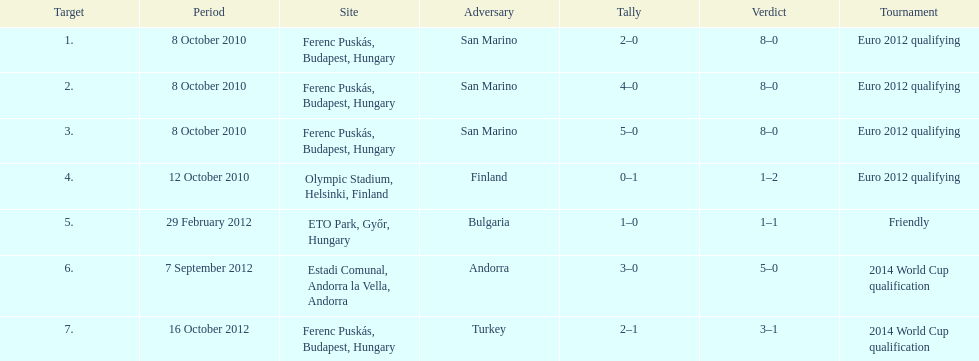How many games did he score but his team lost? 1. 